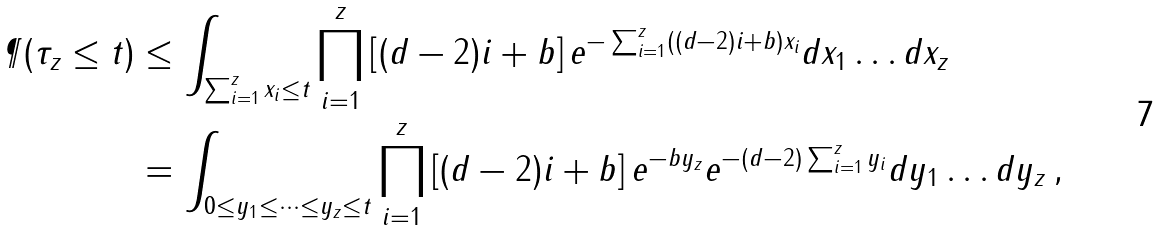Convert formula to latex. <formula><loc_0><loc_0><loc_500><loc_500>\P ( \tau _ { z } \leq t ) & \leq \int _ { \sum _ { i = 1 } ^ { z } x _ { i } \leq t } \prod _ { i = 1 } ^ { z } \left [ ( d - 2 ) i + b \right ] e ^ { - \sum _ { i = 1 } ^ { z } ( ( d - 2 ) i + b ) x _ { i } } d x _ { 1 } \dots d x _ { z } \\ & = \int _ { 0 \leq y _ { 1 } \leq \dots \leq y _ { z } \leq t } \prod _ { i = 1 } ^ { z } \left [ ( d - 2 ) i + b \right ] e ^ { - b y _ { z } } e ^ { - ( d - 2 ) \sum _ { i = 1 } ^ { z } y _ { i } } d y _ { 1 } \dots d y _ { z } \, ,</formula> 